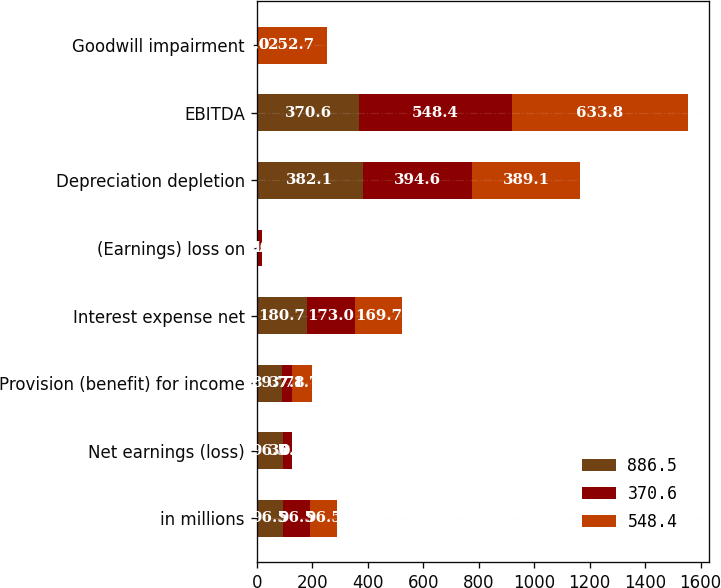Convert chart to OTSL. <chart><loc_0><loc_0><loc_500><loc_500><stacked_bar_chart><ecel><fcel>in millions<fcel>Net earnings (loss)<fcel>Provision (benefit) for income<fcel>Interest expense net<fcel>(Earnings) loss on<fcel>Depreciation depletion<fcel>EBITDA<fcel>Goodwill impairment<nl><fcel>886.5<fcel>96.5<fcel>96.5<fcel>89.7<fcel>180.7<fcel>6<fcel>382.1<fcel>370.6<fcel>0<nl><fcel>370.6<fcel>96.5<fcel>30.3<fcel>37.8<fcel>173<fcel>11.7<fcel>394.6<fcel>548.4<fcel>0<nl><fcel>548.4<fcel>96.5<fcel>0.9<fcel>71.7<fcel>169.7<fcel>2.4<fcel>389.1<fcel>633.8<fcel>252.7<nl></chart> 